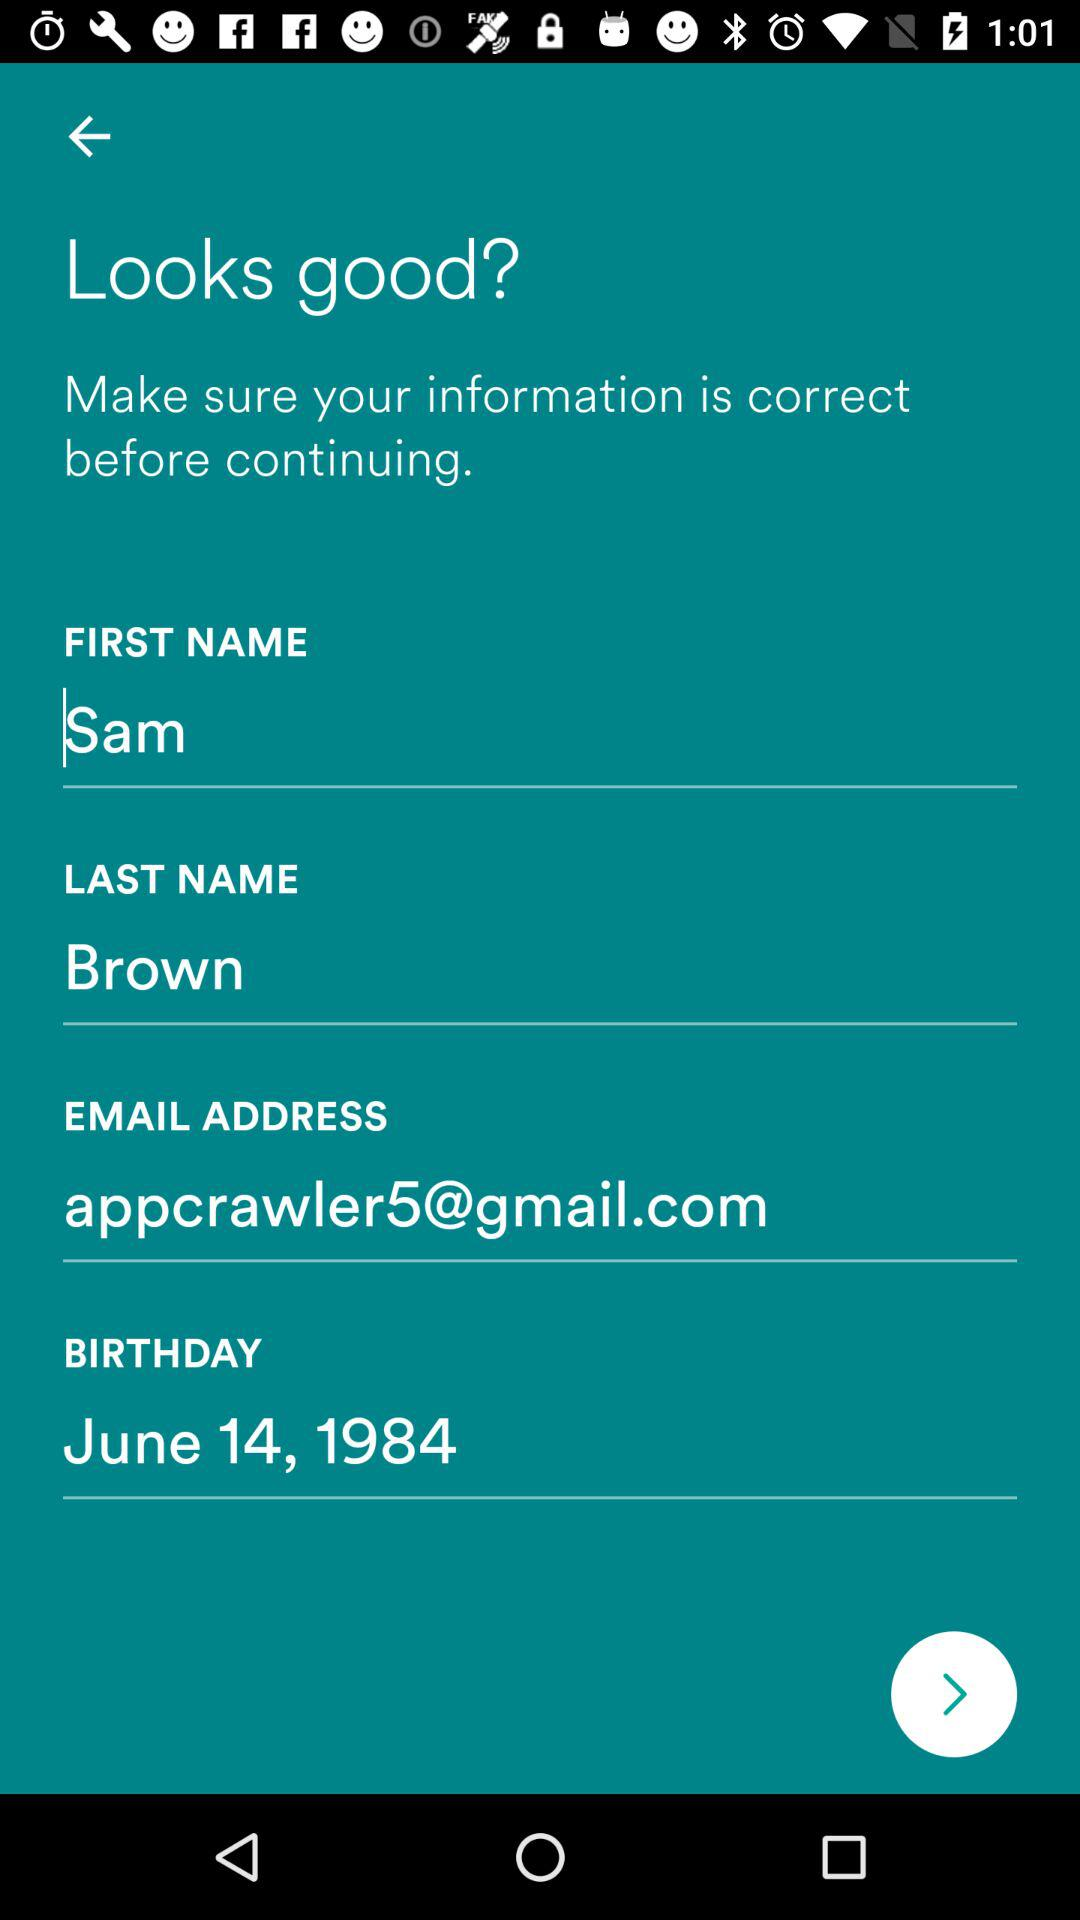What is the user's surname? The user's surname is Brown. 